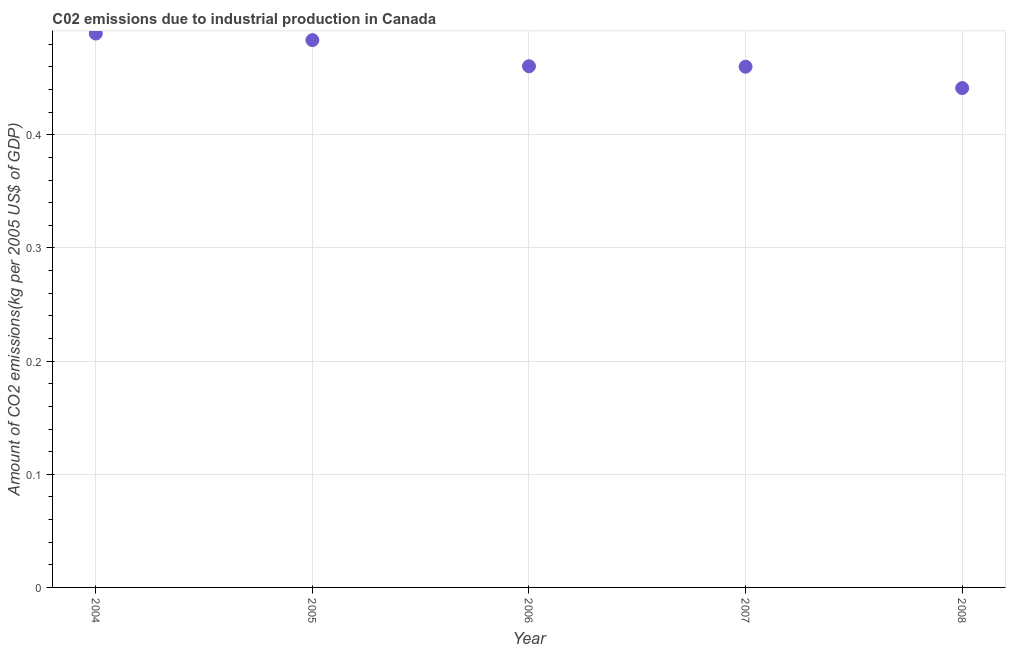What is the amount of co2 emissions in 2007?
Offer a very short reply. 0.46. Across all years, what is the maximum amount of co2 emissions?
Make the answer very short. 0.49. Across all years, what is the minimum amount of co2 emissions?
Give a very brief answer. 0.44. In which year was the amount of co2 emissions maximum?
Your response must be concise. 2004. In which year was the amount of co2 emissions minimum?
Your response must be concise. 2008. What is the sum of the amount of co2 emissions?
Give a very brief answer. 2.34. What is the difference between the amount of co2 emissions in 2006 and 2008?
Offer a very short reply. 0.02. What is the average amount of co2 emissions per year?
Your answer should be very brief. 0.47. What is the median amount of co2 emissions?
Keep it short and to the point. 0.46. Do a majority of the years between 2005 and 2004 (inclusive) have amount of co2 emissions greater than 0.4 kg per 2005 US$ of GDP?
Your answer should be very brief. No. What is the ratio of the amount of co2 emissions in 2005 to that in 2008?
Offer a terse response. 1.1. Is the difference between the amount of co2 emissions in 2004 and 2007 greater than the difference between any two years?
Give a very brief answer. No. What is the difference between the highest and the second highest amount of co2 emissions?
Make the answer very short. 0.01. Is the sum of the amount of co2 emissions in 2007 and 2008 greater than the maximum amount of co2 emissions across all years?
Make the answer very short. Yes. What is the difference between the highest and the lowest amount of co2 emissions?
Your response must be concise. 0.05. In how many years, is the amount of co2 emissions greater than the average amount of co2 emissions taken over all years?
Offer a very short reply. 2. Are the values on the major ticks of Y-axis written in scientific E-notation?
Keep it short and to the point. No. Does the graph contain grids?
Provide a short and direct response. Yes. What is the title of the graph?
Give a very brief answer. C02 emissions due to industrial production in Canada. What is the label or title of the Y-axis?
Give a very brief answer. Amount of CO2 emissions(kg per 2005 US$ of GDP). What is the Amount of CO2 emissions(kg per 2005 US$ of GDP) in 2004?
Provide a short and direct response. 0.49. What is the Amount of CO2 emissions(kg per 2005 US$ of GDP) in 2005?
Make the answer very short. 0.48. What is the Amount of CO2 emissions(kg per 2005 US$ of GDP) in 2006?
Your answer should be very brief. 0.46. What is the Amount of CO2 emissions(kg per 2005 US$ of GDP) in 2007?
Your answer should be very brief. 0.46. What is the Amount of CO2 emissions(kg per 2005 US$ of GDP) in 2008?
Ensure brevity in your answer.  0.44. What is the difference between the Amount of CO2 emissions(kg per 2005 US$ of GDP) in 2004 and 2005?
Ensure brevity in your answer.  0.01. What is the difference between the Amount of CO2 emissions(kg per 2005 US$ of GDP) in 2004 and 2006?
Provide a succinct answer. 0.03. What is the difference between the Amount of CO2 emissions(kg per 2005 US$ of GDP) in 2004 and 2007?
Your answer should be very brief. 0.03. What is the difference between the Amount of CO2 emissions(kg per 2005 US$ of GDP) in 2004 and 2008?
Your answer should be very brief. 0.05. What is the difference between the Amount of CO2 emissions(kg per 2005 US$ of GDP) in 2005 and 2006?
Your response must be concise. 0.02. What is the difference between the Amount of CO2 emissions(kg per 2005 US$ of GDP) in 2005 and 2007?
Provide a succinct answer. 0.02. What is the difference between the Amount of CO2 emissions(kg per 2005 US$ of GDP) in 2005 and 2008?
Give a very brief answer. 0.04. What is the difference between the Amount of CO2 emissions(kg per 2005 US$ of GDP) in 2006 and 2008?
Give a very brief answer. 0.02. What is the difference between the Amount of CO2 emissions(kg per 2005 US$ of GDP) in 2007 and 2008?
Offer a terse response. 0.02. What is the ratio of the Amount of CO2 emissions(kg per 2005 US$ of GDP) in 2004 to that in 2006?
Provide a short and direct response. 1.06. What is the ratio of the Amount of CO2 emissions(kg per 2005 US$ of GDP) in 2004 to that in 2007?
Your response must be concise. 1.06. What is the ratio of the Amount of CO2 emissions(kg per 2005 US$ of GDP) in 2004 to that in 2008?
Give a very brief answer. 1.11. What is the ratio of the Amount of CO2 emissions(kg per 2005 US$ of GDP) in 2005 to that in 2006?
Your answer should be compact. 1.05. What is the ratio of the Amount of CO2 emissions(kg per 2005 US$ of GDP) in 2005 to that in 2007?
Provide a short and direct response. 1.05. What is the ratio of the Amount of CO2 emissions(kg per 2005 US$ of GDP) in 2005 to that in 2008?
Give a very brief answer. 1.1. What is the ratio of the Amount of CO2 emissions(kg per 2005 US$ of GDP) in 2006 to that in 2007?
Provide a succinct answer. 1. What is the ratio of the Amount of CO2 emissions(kg per 2005 US$ of GDP) in 2006 to that in 2008?
Your answer should be very brief. 1.04. What is the ratio of the Amount of CO2 emissions(kg per 2005 US$ of GDP) in 2007 to that in 2008?
Your response must be concise. 1.04. 